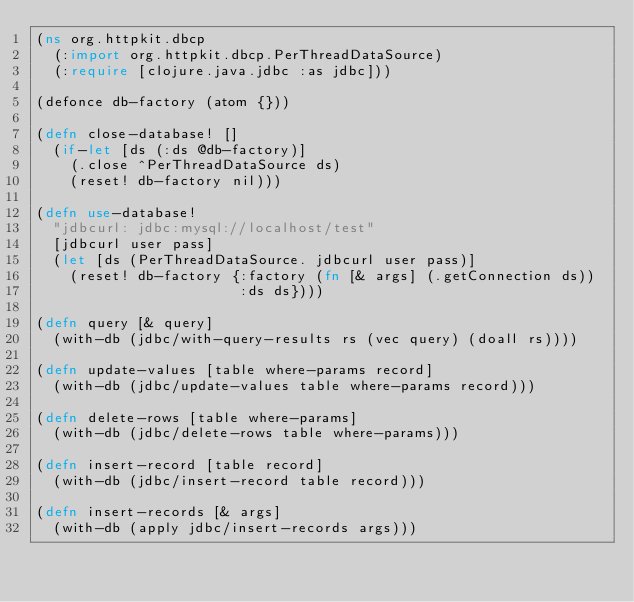Convert code to text. <code><loc_0><loc_0><loc_500><loc_500><_Clojure_>(ns org.httpkit.dbcp
  (:import org.httpkit.dbcp.PerThreadDataSource)
  (:require [clojure.java.jdbc :as jdbc]))

(defonce db-factory (atom {}))

(defn close-database! []
  (if-let [ds (:ds @db-factory)]
    (.close ^PerThreadDataSource ds)
    (reset! db-factory nil)))

(defn use-database!
  "jdbcurl: jdbc:mysql://localhost/test"
  [jdbcurl user pass]
  (let [ds (PerThreadDataSource. jdbcurl user pass)]
    (reset! db-factory {:factory (fn [& args] (.getConnection ds))
                        :ds ds})))

(defn query [& query]
  (with-db (jdbc/with-query-results rs (vec query) (doall rs))))

(defn update-values [table where-params record]
  (with-db (jdbc/update-values table where-params record)))

(defn delete-rows [table where-params]
  (with-db (jdbc/delete-rows table where-params)))

(defn insert-record [table record]
  (with-db (jdbc/insert-record table record)))

(defn insert-records [& args]
  (with-db (apply jdbc/insert-records args)))
</code> 